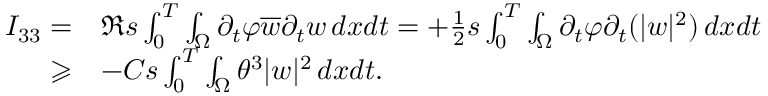Convert formula to latex. <formula><loc_0><loc_0><loc_500><loc_500>\begin{array} { r l } { I _ { 3 3 } = } & { \Re s \int _ { 0 } ^ { T } \int _ { \Omega } \partial _ { t } \varphi \overline { w } \partial _ { t } w \, d x d t = + \frac { 1 } { 2 } s \int _ { 0 } ^ { T } \int _ { \Omega } \partial _ { t } \varphi \partial _ { t } ( | w | ^ { 2 } ) \, d x d t } \\ { \geqslant } & { - C s \int _ { 0 } ^ { T } \int _ { \Omega } \theta ^ { 3 } | w | ^ { 2 } \, d x d t . } \end{array}</formula> 